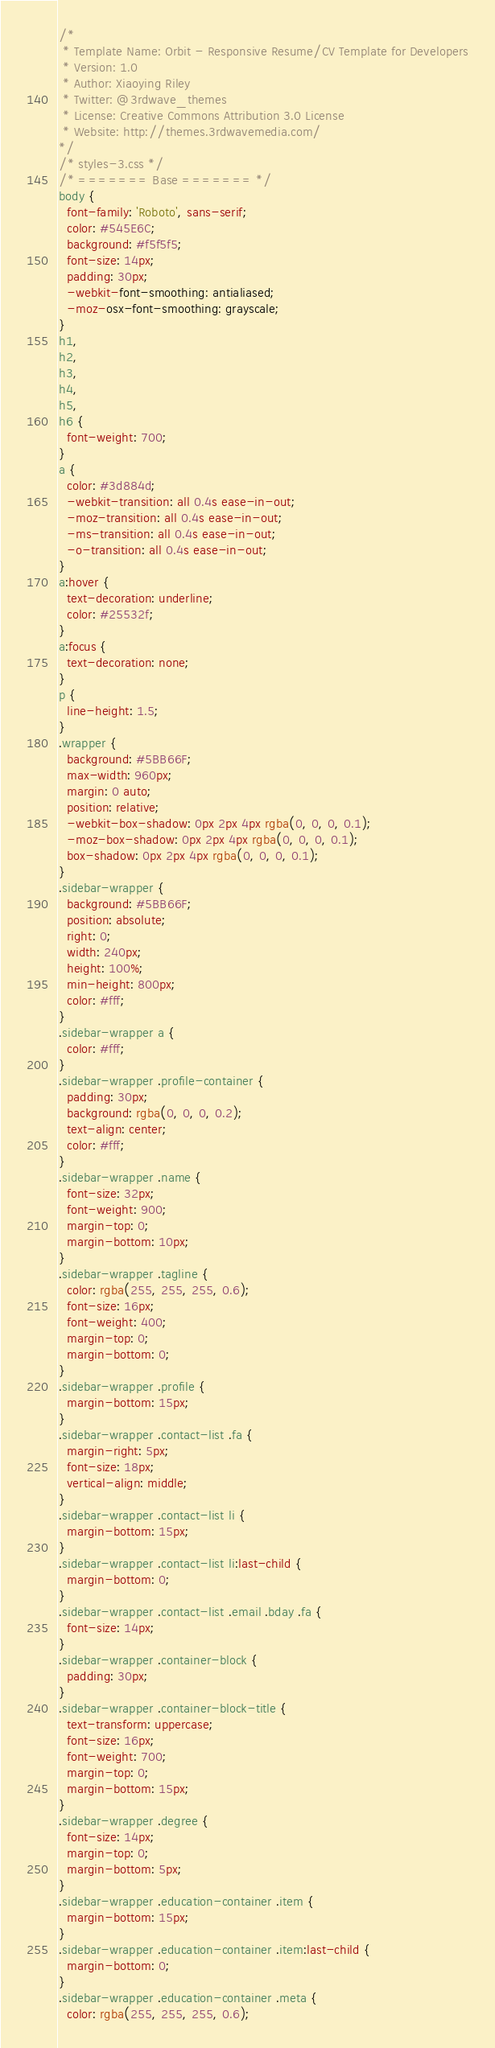<code> <loc_0><loc_0><loc_500><loc_500><_CSS_>/*
 * Template Name: Orbit - Responsive Resume/CV Template for Developers
 * Version: 1.0
 * Author: Xiaoying Riley
 * Twitter: @3rdwave_themes
 * License: Creative Commons Attribution 3.0 License
 * Website: http://themes.3rdwavemedia.com/
*/
/* styles-3.css */
/* ======= Base ======= */
body {
  font-family: 'Roboto', sans-serif;
  color: #545E6C;
  background: #f5f5f5;
  font-size: 14px;
  padding: 30px;
  -webkit-font-smoothing: antialiased;
  -moz-osx-font-smoothing: grayscale;
}
h1,
h2,
h3,
h4,
h5,
h6 {
  font-weight: 700;
}
a {
  color: #3d884d;
  -webkit-transition: all 0.4s ease-in-out;
  -moz-transition: all 0.4s ease-in-out;
  -ms-transition: all 0.4s ease-in-out;
  -o-transition: all 0.4s ease-in-out;
}
a:hover {
  text-decoration: underline;
  color: #25532f;
}
a:focus {
  text-decoration: none;
}
p {
  line-height: 1.5;
}
.wrapper {
  background: #5BB66F;
  max-width: 960px;
  margin: 0 auto;
  position: relative;
  -webkit-box-shadow: 0px 2px 4px rgba(0, 0, 0, 0.1);
  -moz-box-shadow: 0px 2px 4px rgba(0, 0, 0, 0.1);
  box-shadow: 0px 2px 4px rgba(0, 0, 0, 0.1);
}
.sidebar-wrapper {
  background: #5BB66F;
  position: absolute;
  right: 0;
  width: 240px;
  height: 100%;
  min-height: 800px;
  color: #fff;
}
.sidebar-wrapper a {
  color: #fff;
}
.sidebar-wrapper .profile-container {
  padding: 30px;
  background: rgba(0, 0, 0, 0.2);
  text-align: center;
  color: #fff;
}
.sidebar-wrapper .name {
  font-size: 32px;
  font-weight: 900;
  margin-top: 0;
  margin-bottom: 10px;
}
.sidebar-wrapper .tagline {
  color: rgba(255, 255, 255, 0.6);
  font-size: 16px;
  font-weight: 400;
  margin-top: 0;
  margin-bottom: 0;
}
.sidebar-wrapper .profile {
  margin-bottom: 15px;
}
.sidebar-wrapper .contact-list .fa {
  margin-right: 5px;
  font-size: 18px;
  vertical-align: middle;
}
.sidebar-wrapper .contact-list li {
  margin-bottom: 15px;
}
.sidebar-wrapper .contact-list li:last-child {
  margin-bottom: 0;
}
.sidebar-wrapper .contact-list .email .bday .fa {
  font-size: 14px;
}
.sidebar-wrapper .container-block {
  padding: 30px;
}
.sidebar-wrapper .container-block-title {
  text-transform: uppercase;
  font-size: 16px;
  font-weight: 700;
  margin-top: 0;
  margin-bottom: 15px;
}
.sidebar-wrapper .degree {
  font-size: 14px;
  margin-top: 0;
  margin-bottom: 5px;
}
.sidebar-wrapper .education-container .item {
  margin-bottom: 15px;
}
.sidebar-wrapper .education-container .item:last-child {
  margin-bottom: 0;
}
.sidebar-wrapper .education-container .meta {
  color: rgba(255, 255, 255, 0.6);</code> 